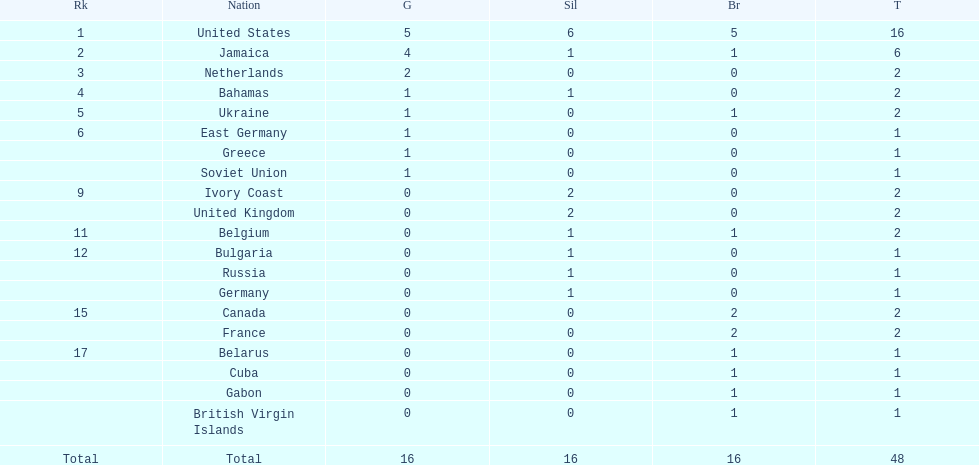What country won more gold medals than any other? United States. 